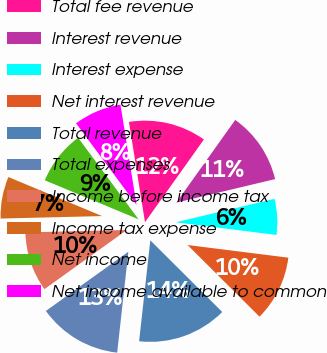Convert chart to OTSL. <chart><loc_0><loc_0><loc_500><loc_500><pie_chart><fcel>Total fee revenue<fcel>Interest revenue<fcel>Interest expense<fcel>Net interest revenue<fcel>Total revenue<fcel>Total expenses<fcel>Income before income tax<fcel>Income tax expense<fcel>Net income<fcel>Net income available to common<nl><fcel>12.38%<fcel>11.43%<fcel>5.71%<fcel>10.48%<fcel>14.29%<fcel>13.33%<fcel>9.52%<fcel>6.67%<fcel>8.57%<fcel>7.62%<nl></chart> 